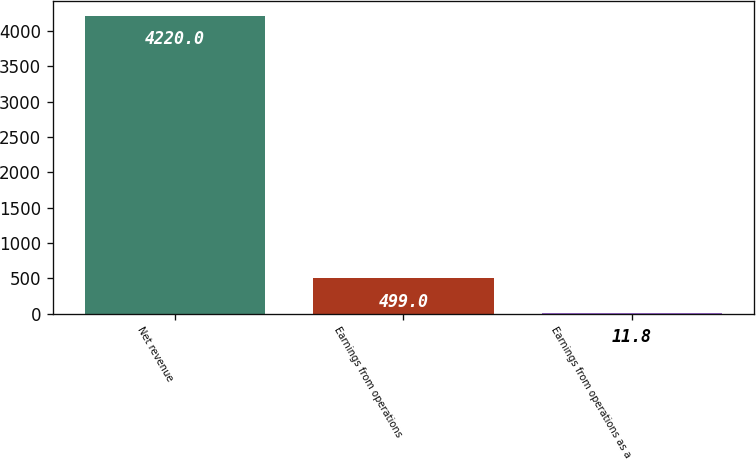Convert chart to OTSL. <chart><loc_0><loc_0><loc_500><loc_500><bar_chart><fcel>Net revenue<fcel>Earnings from operations<fcel>Earnings from operations as a<nl><fcel>4220<fcel>499<fcel>11.8<nl></chart> 